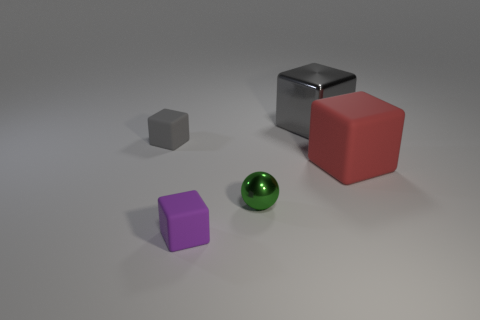How many big objects are either gray metal spheres or rubber things?
Give a very brief answer. 1. What number of other things are there of the same color as the tiny sphere?
Your answer should be compact. 0. What number of other red blocks have the same material as the red cube?
Your response must be concise. 0. Is the color of the shiny thing behind the small green sphere the same as the tiny metallic ball?
Offer a very short reply. No. How many blue objects are small things or large shiny blocks?
Provide a short and direct response. 0. Are there any other things that have the same material as the big red thing?
Your answer should be very brief. Yes. Is the gray block right of the tiny green metal ball made of the same material as the tiny gray block?
Your response must be concise. No. What number of things are big gray metallic cubes or blocks left of the purple object?
Your response must be concise. 2. There is a thing that is to the left of the small object in front of the small green metallic ball; how many things are behind it?
Your answer should be very brief. 1. Does the gray object in front of the gray shiny object have the same shape as the tiny green thing?
Ensure brevity in your answer.  No. 